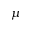Convert formula to latex. <formula><loc_0><loc_0><loc_500><loc_500>\mu</formula> 